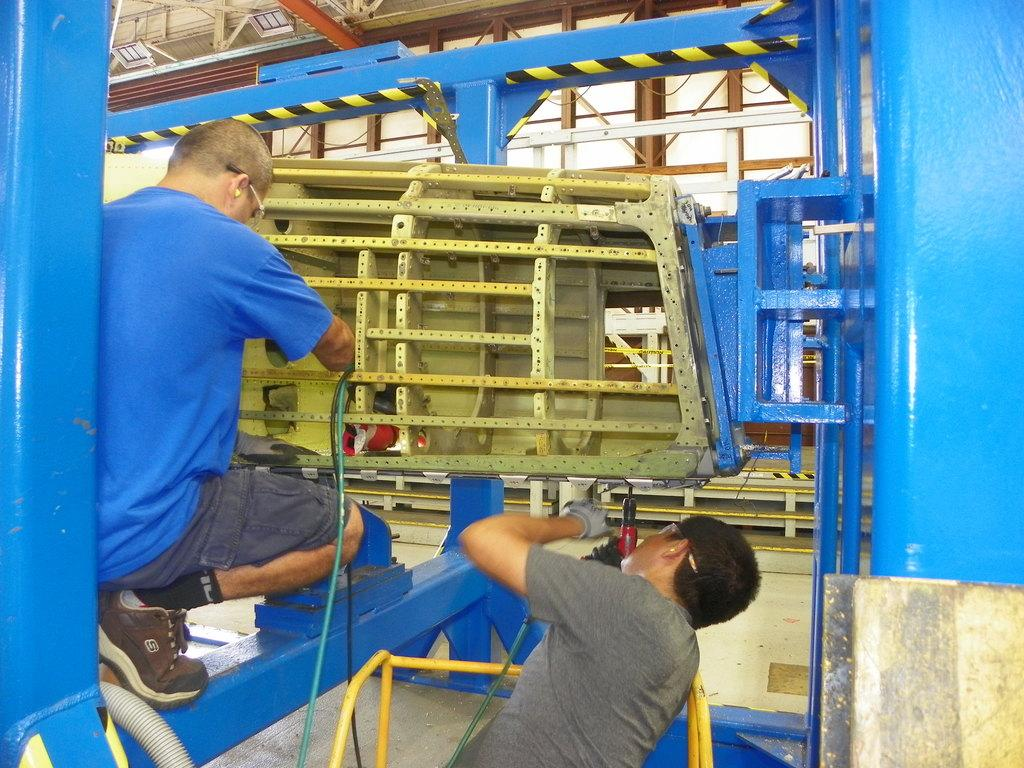How many workers are present in the image? There are two workers in the image. What are the workers doing in the image? The workers are fixing a metal object. What are the workers holding in their hands? The workers are holding tools in their hands. What can be seen in the background of the image? There are metal rods in the background of the image. What type of jewel is being used as a tool by the workers in the image? There are no jewels present in the image; the workers are holding tools made of metal or other materials. 